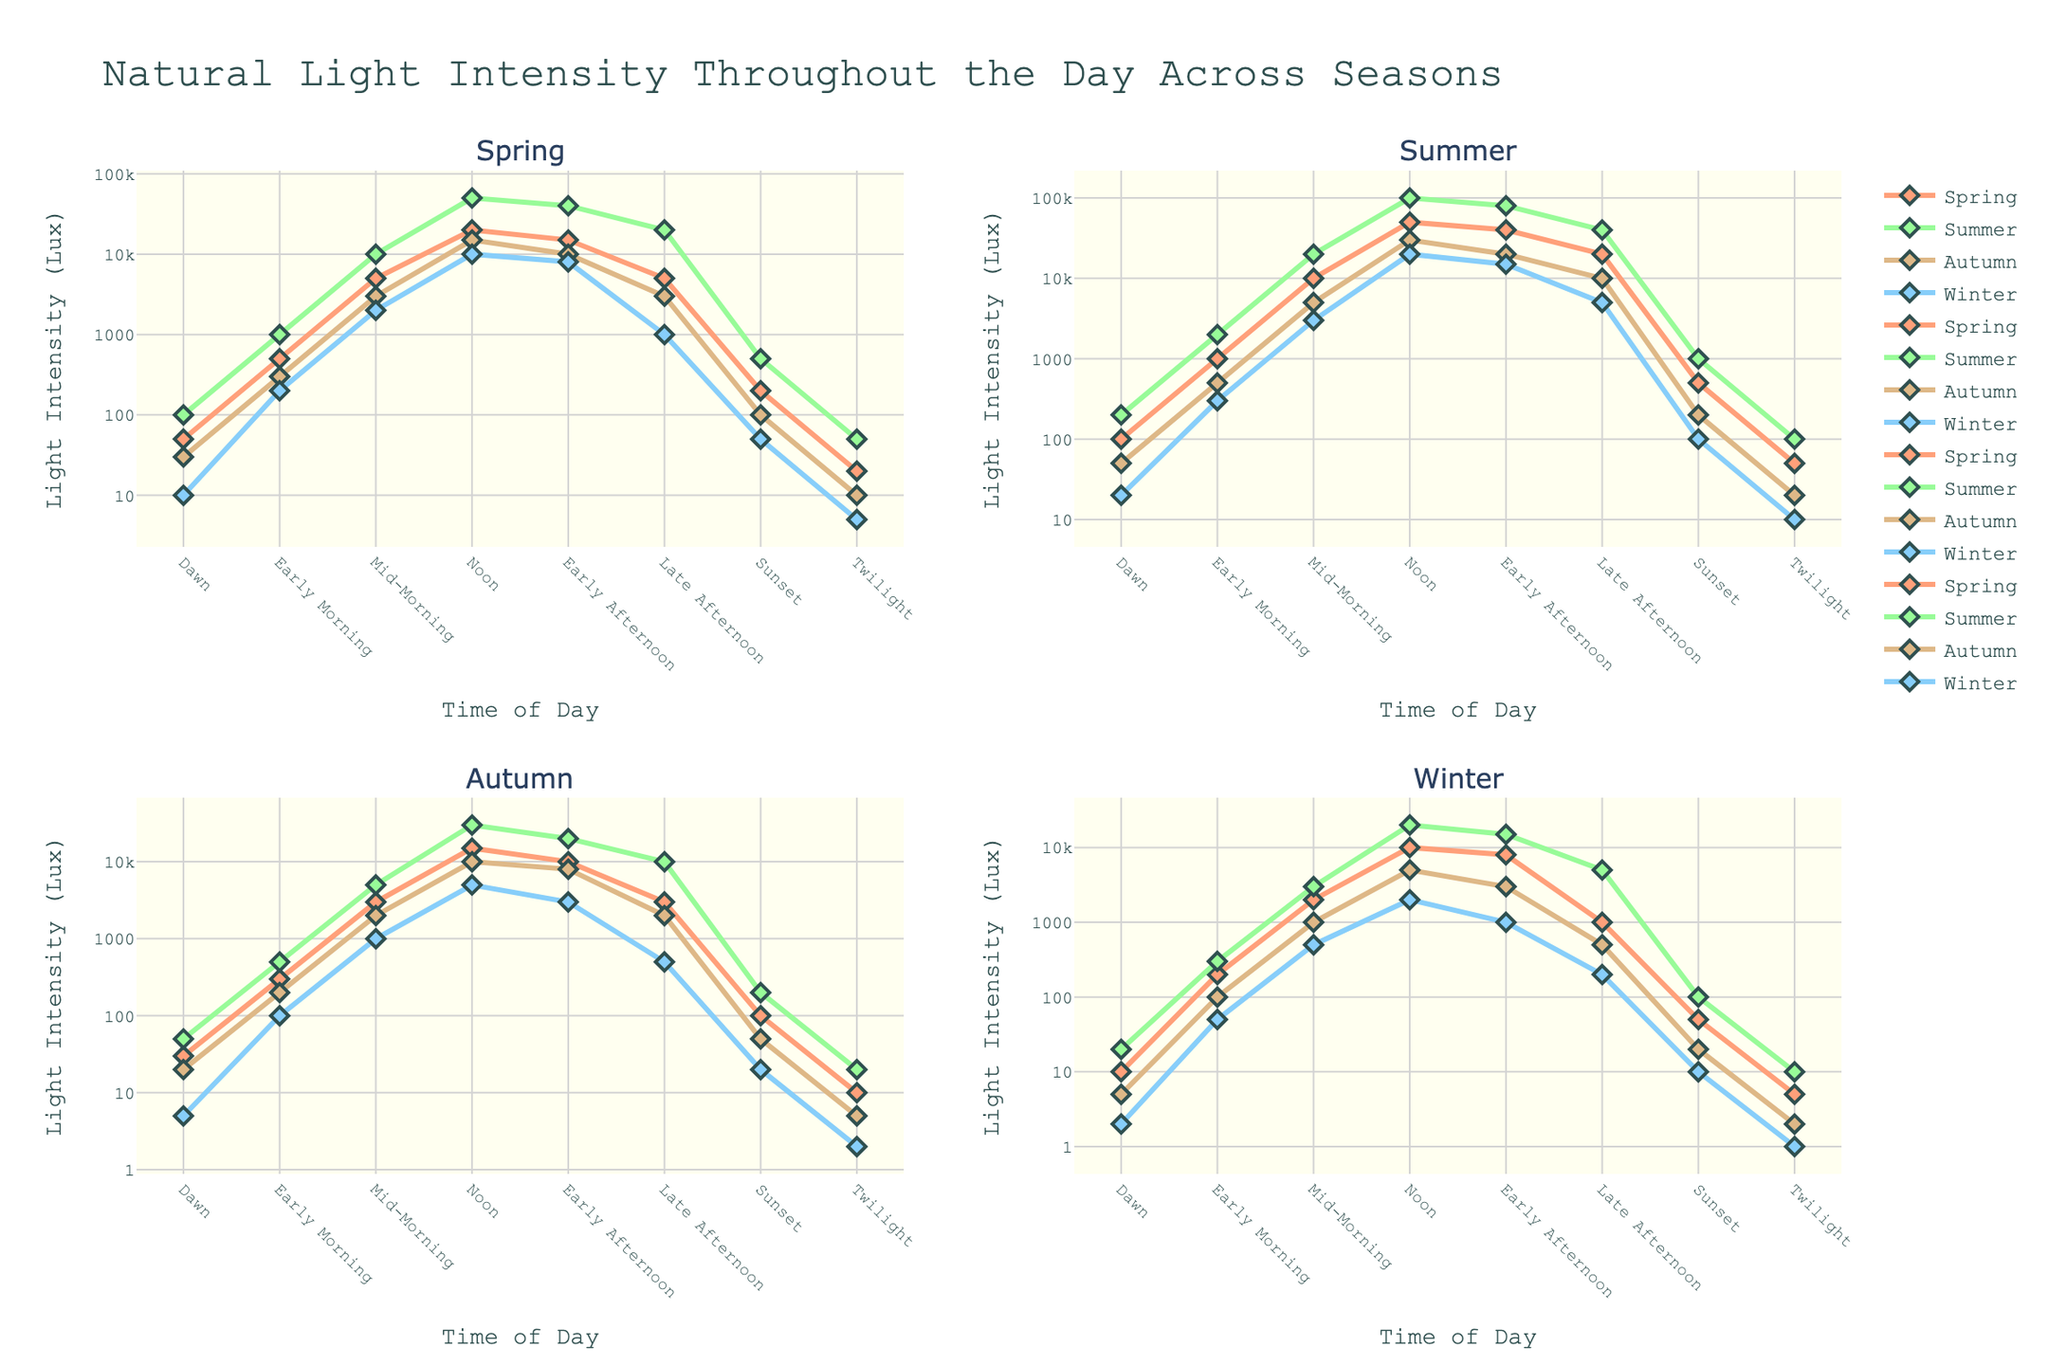What time of day does Summer reach its peak light intensity? By examining the line for Summer in each subplot, we observe that the highest light intensity for Summer occurs at Noon.
Answer: Noon Comparing the Mid-Morning light intensities, which season has the highest value? Looking at the Mid-Morning light intensities, Summer has the highest value with 20000 Lux.
Answer: Summer How does light intensity at Early Afternoon in Spring compare to that in Winter? The Early Afternoon light intensity in Spring is 15000 Lux, whereas in Winter, it is 8000 Lux. Therefore, Spring has a higher light intensity.
Answer: Spring What is the average light intensity at Twilight across all seasons? Adding Twilight light intensities for all seasons: (20 + 50 + 10 + 5) + (50 + 100 + 20 + 10) + (10 + 20 + 5 + 2) + (5 + 10 + 2 + 1), and then dividing by 4 gives us the average Twilight light intensity: (85 + 180 + 37 + 18) / 4 = 320 / 4 = 80
Answer: 80 Lux Is the Early Morning light intensity in Autumn greater than the Sunset light intensity in Summer? The Early Morning light intensity in Autumn is 500 Lux, and the Sunset light intensity in Summer is 1000 Lux. Comparing them, 500 Lux < 1000 Lux.
Answer: No Which season shows the most significant change in light intensity from Dawn to Noon? Observing the difference in values from Dawn to Noon for each season: Spring (50 to 20000), Summer (100 to 100000), Autumn (30 to 30000), Winter (10 to 20000). Summer shows the most significant change of 99900 Lux.
Answer: Summer At Late Afternoon, which season has the lowest light intensity? By observing the Late Afternoon light intensities of each season: Spring (5000), Summer (20000), Autumn (3000), Winter (1000), we see that Winter has the lowest at 1000 Lux.
Answer: Winter In which season is the Dawn light intensity the highest? By comparing the Dawn light intensities in each subplot: Spring (50), Summer (100), Autumn (30), Winter (10). Summer has the highest at 100 Lux.
Answer: Summer 